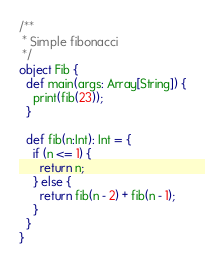<code> <loc_0><loc_0><loc_500><loc_500><_Scala_>/**
 * Simple fibonacci
 */
object Fib {
  def main(args: Array[String]) {
    print(fib(23));
  }

  def fib(n:Int): Int = {
    if (n <= 1) {
      return n;
    } else {
      return fib(n - 2) + fib(n - 1);
    }
  }
}
</code> 